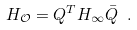<formula> <loc_0><loc_0><loc_500><loc_500>H _ { \mathcal { O } } = Q ^ { T } H _ { \infty } \bar { Q } \ .</formula> 